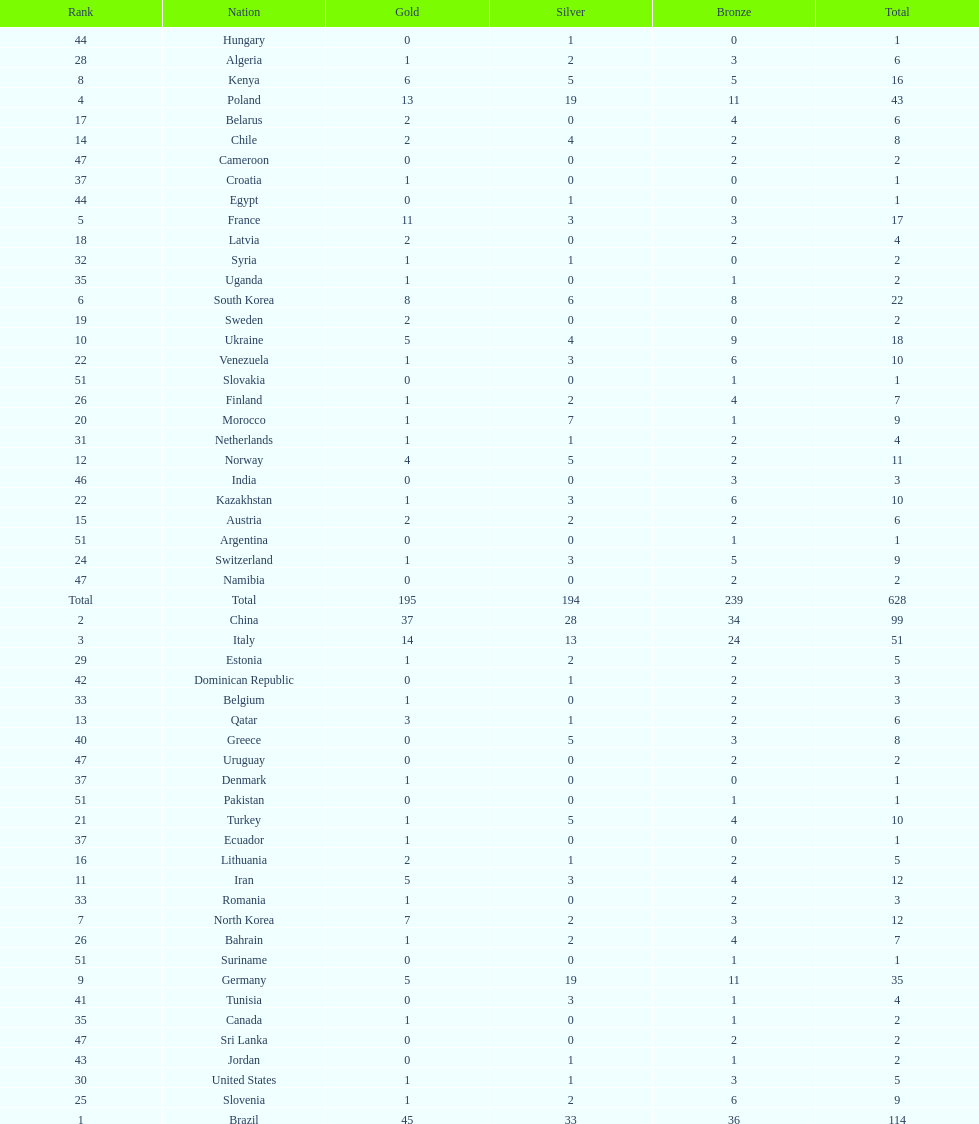Which nation earned the most gold medals? Brazil. 